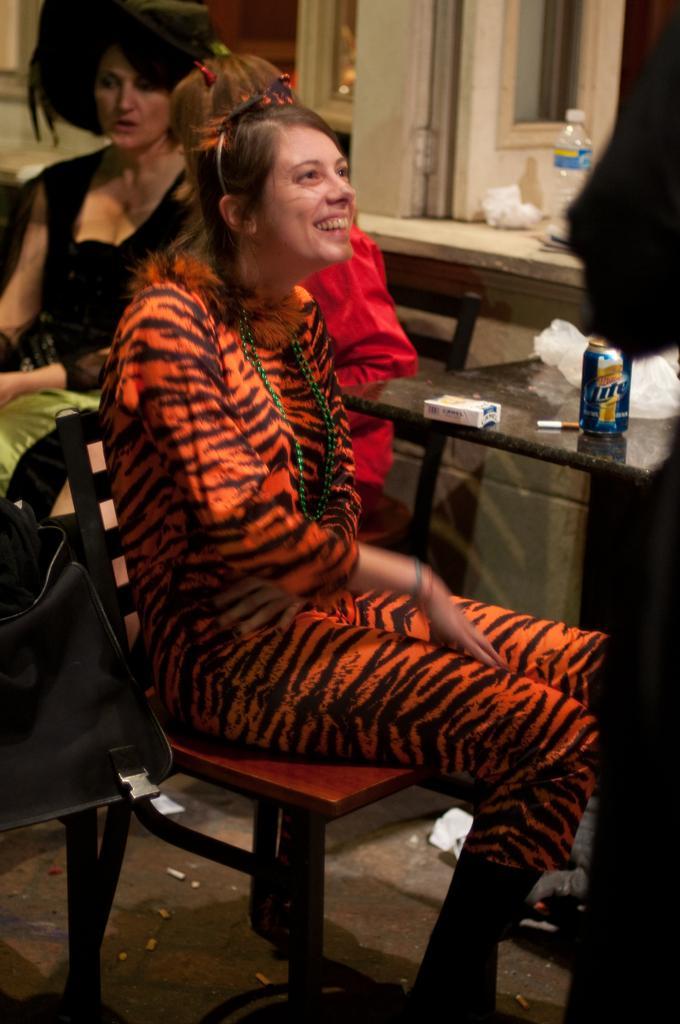Can you describe this image briefly? In the front on the chair there is a lady sitting with orange and black color dress. She is smiling. Beside her there is a table with tin, cigar and packet on it. Behind the lady there is another lady with black dress. She is sitting on the chair. To the right side top there is a window and a bottle. 